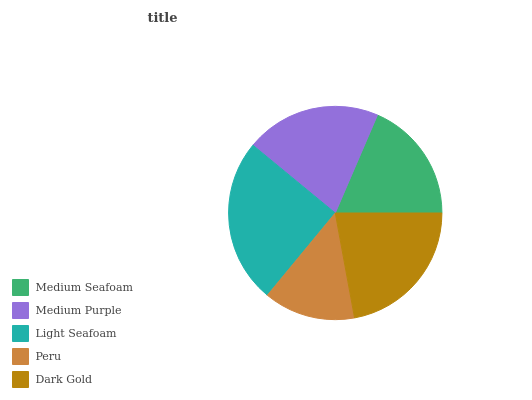Is Peru the minimum?
Answer yes or no. Yes. Is Light Seafoam the maximum?
Answer yes or no. Yes. Is Medium Purple the minimum?
Answer yes or no. No. Is Medium Purple the maximum?
Answer yes or no. No. Is Medium Purple greater than Medium Seafoam?
Answer yes or no. Yes. Is Medium Seafoam less than Medium Purple?
Answer yes or no. Yes. Is Medium Seafoam greater than Medium Purple?
Answer yes or no. No. Is Medium Purple less than Medium Seafoam?
Answer yes or no. No. Is Medium Purple the high median?
Answer yes or no. Yes. Is Medium Purple the low median?
Answer yes or no. Yes. Is Light Seafoam the high median?
Answer yes or no. No. Is Peru the low median?
Answer yes or no. No. 